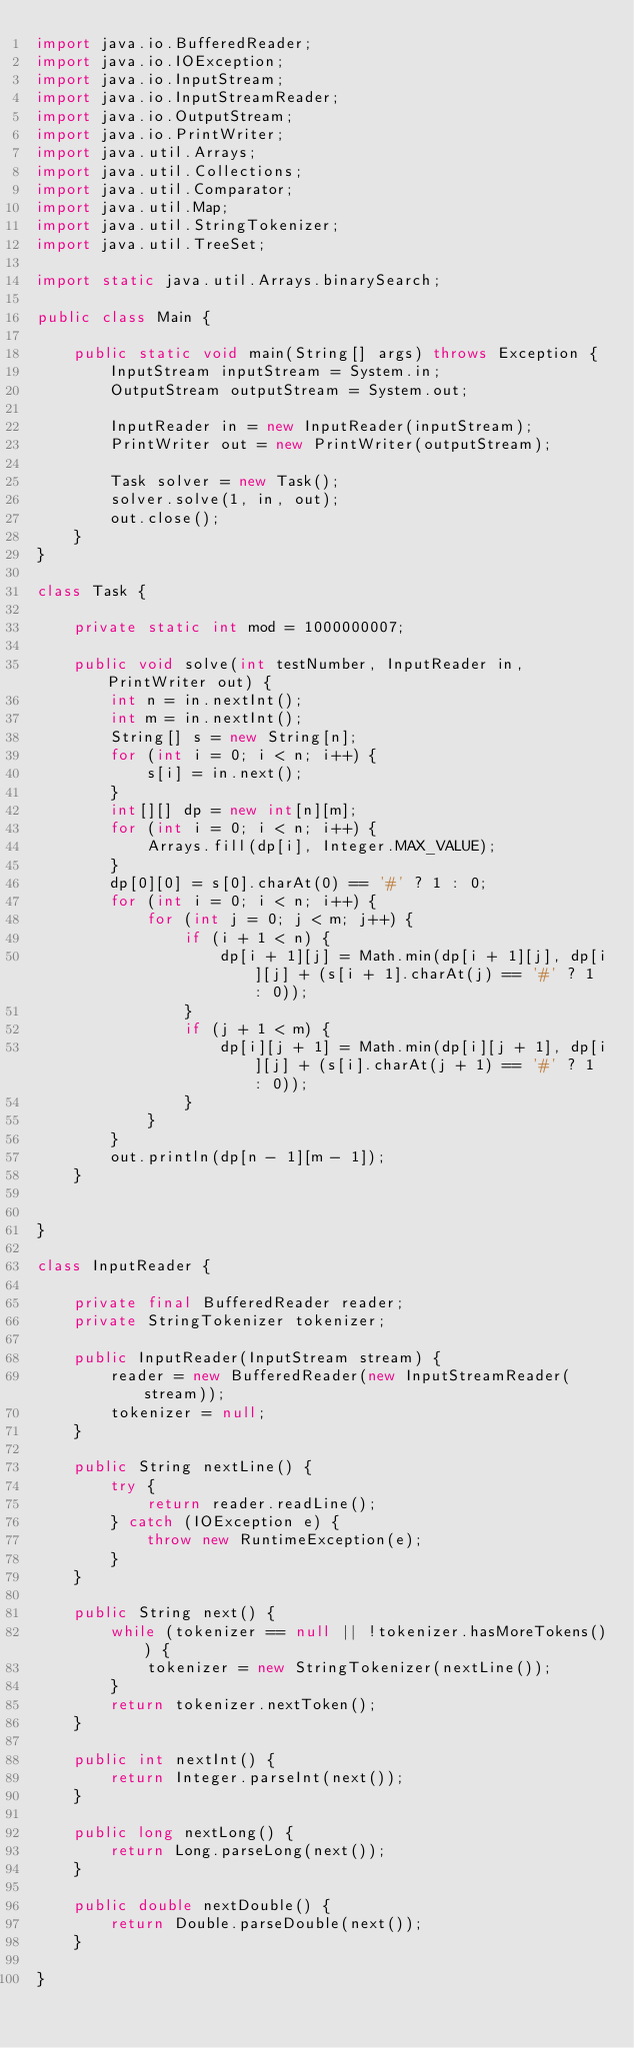<code> <loc_0><loc_0><loc_500><loc_500><_Java_>import java.io.BufferedReader;
import java.io.IOException;
import java.io.InputStream;
import java.io.InputStreamReader;
import java.io.OutputStream;
import java.io.PrintWriter;
import java.util.Arrays;
import java.util.Collections;
import java.util.Comparator;
import java.util.Map;
import java.util.StringTokenizer;
import java.util.TreeSet;

import static java.util.Arrays.binarySearch;

public class Main {

    public static void main(String[] args) throws Exception {
        InputStream inputStream = System.in;
        OutputStream outputStream = System.out;

        InputReader in = new InputReader(inputStream);
        PrintWriter out = new PrintWriter(outputStream);

        Task solver = new Task();
        solver.solve(1, in, out);
        out.close();
    }
}

class Task {

    private static int mod = 1000000007;

    public void solve(int testNumber, InputReader in, PrintWriter out) {
        int n = in.nextInt();
        int m = in.nextInt();
        String[] s = new String[n];
        for (int i = 0; i < n; i++) {
            s[i] = in.next();
        }
        int[][] dp = new int[n][m];
        for (int i = 0; i < n; i++) {
            Arrays.fill(dp[i], Integer.MAX_VALUE);
        }
        dp[0][0] = s[0].charAt(0) == '#' ? 1 : 0;
        for (int i = 0; i < n; i++) {
            for (int j = 0; j < m; j++) {
                if (i + 1 < n) {
                    dp[i + 1][j] = Math.min(dp[i + 1][j], dp[i][j] + (s[i + 1].charAt(j) == '#' ? 1 : 0));
                }
                if (j + 1 < m) {
                    dp[i][j + 1] = Math.min(dp[i][j + 1], dp[i][j] + (s[i].charAt(j + 1) == '#' ? 1 : 0));
                }
            }
        }
        out.println(dp[n - 1][m - 1]);
    }


}

class InputReader {

    private final BufferedReader reader;
    private StringTokenizer tokenizer;

    public InputReader(InputStream stream) {
        reader = new BufferedReader(new InputStreamReader(stream));
        tokenizer = null;
    }

    public String nextLine() {
        try {
            return reader.readLine();
        } catch (IOException e) {
            throw new RuntimeException(e);
        }
    }

    public String next() {
        while (tokenizer == null || !tokenizer.hasMoreTokens()) {
            tokenizer = new StringTokenizer(nextLine());
        }
        return tokenizer.nextToken();
    }

    public int nextInt() {
        return Integer.parseInt(next());
    }

    public long nextLong() {
        return Long.parseLong(next());
    }

    public double nextDouble() {
        return Double.parseDouble(next());
    }

}
</code> 